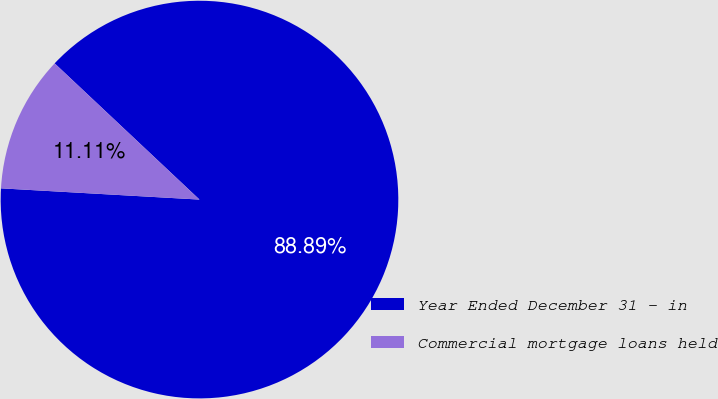Convert chart to OTSL. <chart><loc_0><loc_0><loc_500><loc_500><pie_chart><fcel>Year Ended December 31 - in<fcel>Commercial mortgage loans held<nl><fcel>88.89%<fcel>11.11%<nl></chart> 